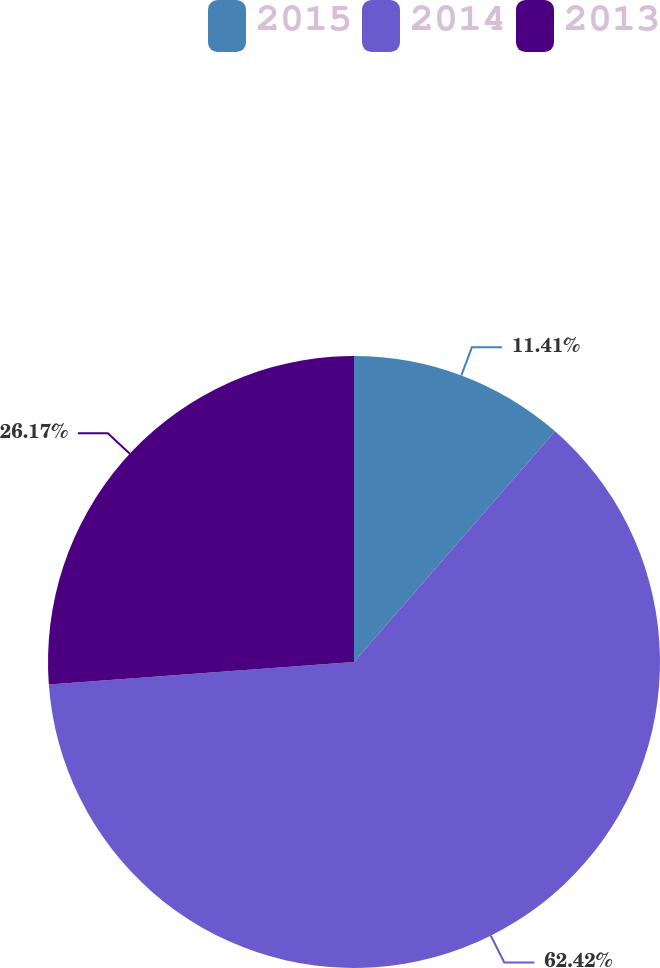Convert chart. <chart><loc_0><loc_0><loc_500><loc_500><pie_chart><fcel>2015<fcel>2014<fcel>2013<nl><fcel>11.41%<fcel>62.42%<fcel>26.17%<nl></chart> 